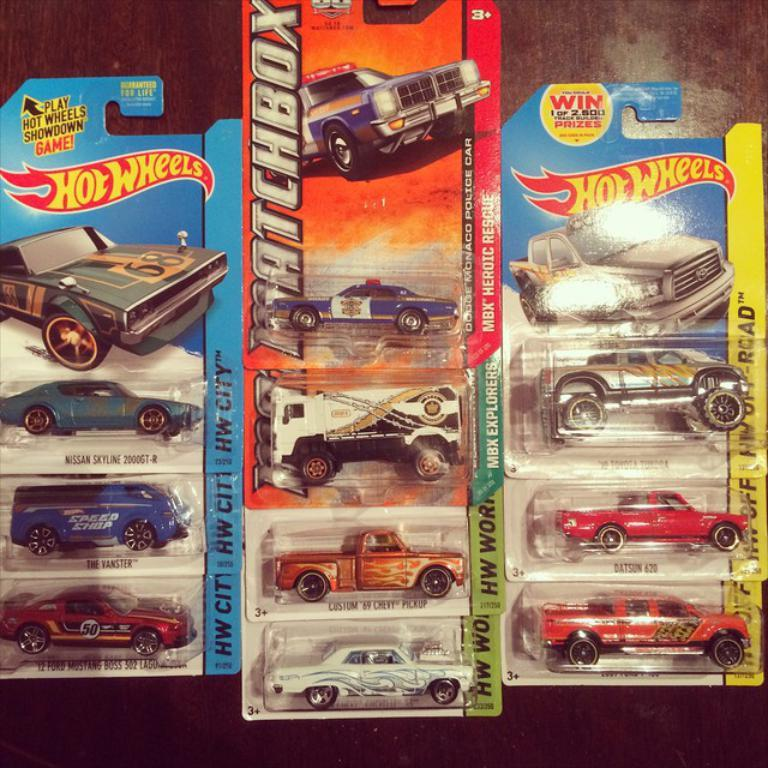What type of toy is present in the image? There are hot wheels in the image. Where are the hot wheels placed? The hot wheels are on a wooden platform. What type of paste is being used to create a sea-like background for the hot wheels in the image? There is no paste or sea-like background present in the image; it only features hot wheels on a wooden platform. 